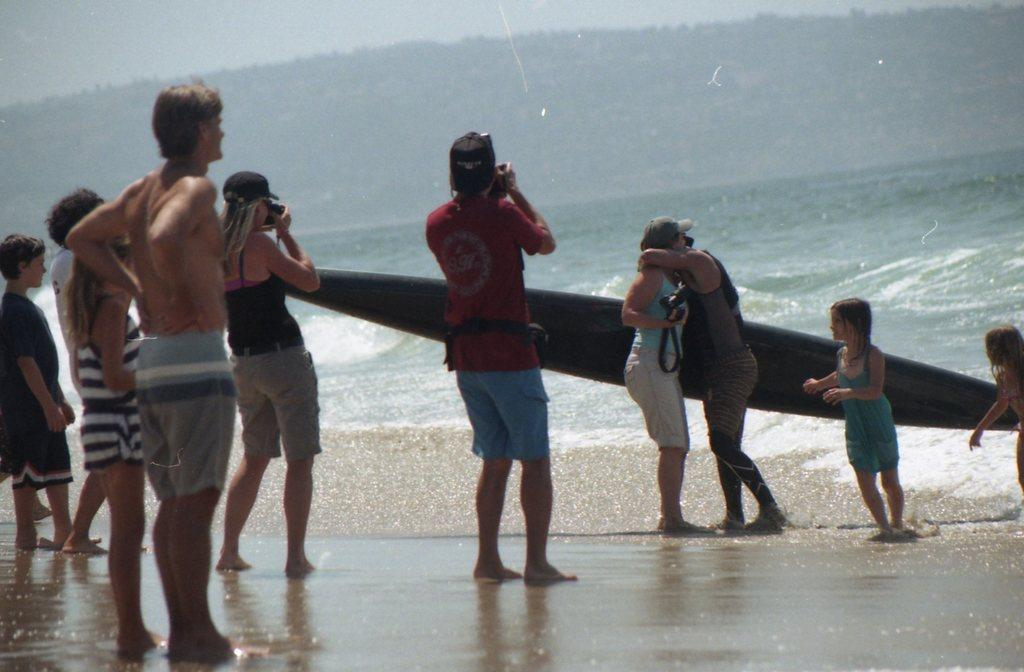What is the general appearance of the background in the image? The background of the image is blurry. What is the main subject of the image? The image depicts a sea. What are the people in the image doing? Some people are standing in front of the sea, and some are taking photographs. What recreational item can be seen in the image? There is a surfboard in the image. What type of humor can be seen in the image? There is no humor depicted in the image; it shows people standing near a sea and a surfboard. Is there a camp visible in the image? There is no camp present in the image; it features a sea, people, and a surfboard. 